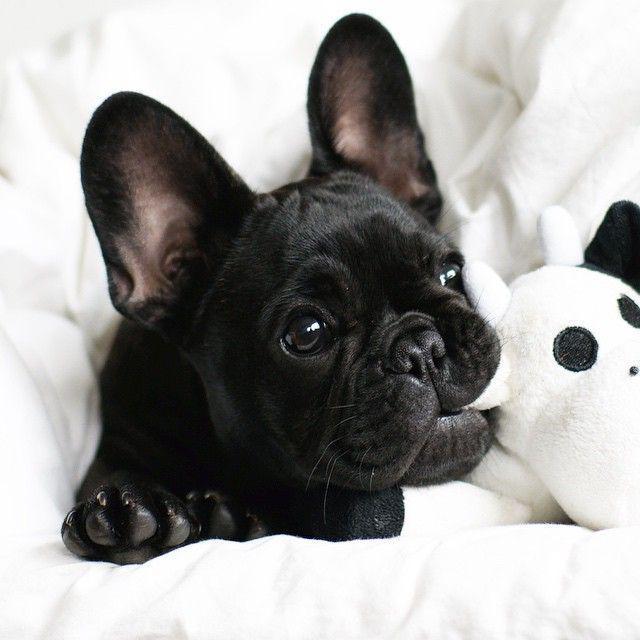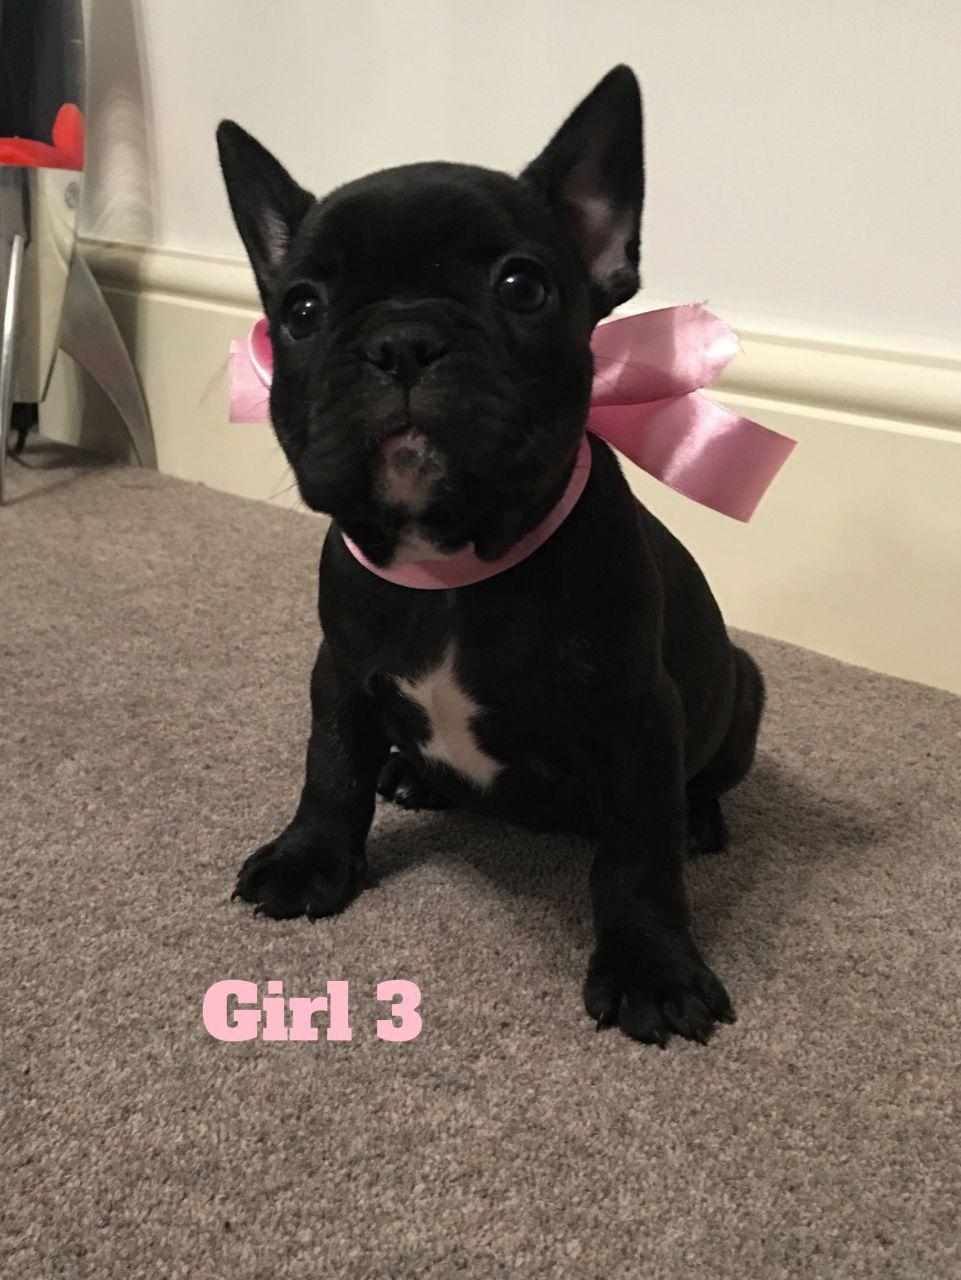The first image is the image on the left, the second image is the image on the right. Examine the images to the left and right. Is the description "The single dog in each image is indoors." accurate? Answer yes or no. Yes. The first image is the image on the left, the second image is the image on the right. For the images shown, is this caption "An image shows a black dog with some type of toy in the side of its mouth." true? Answer yes or no. Yes. 